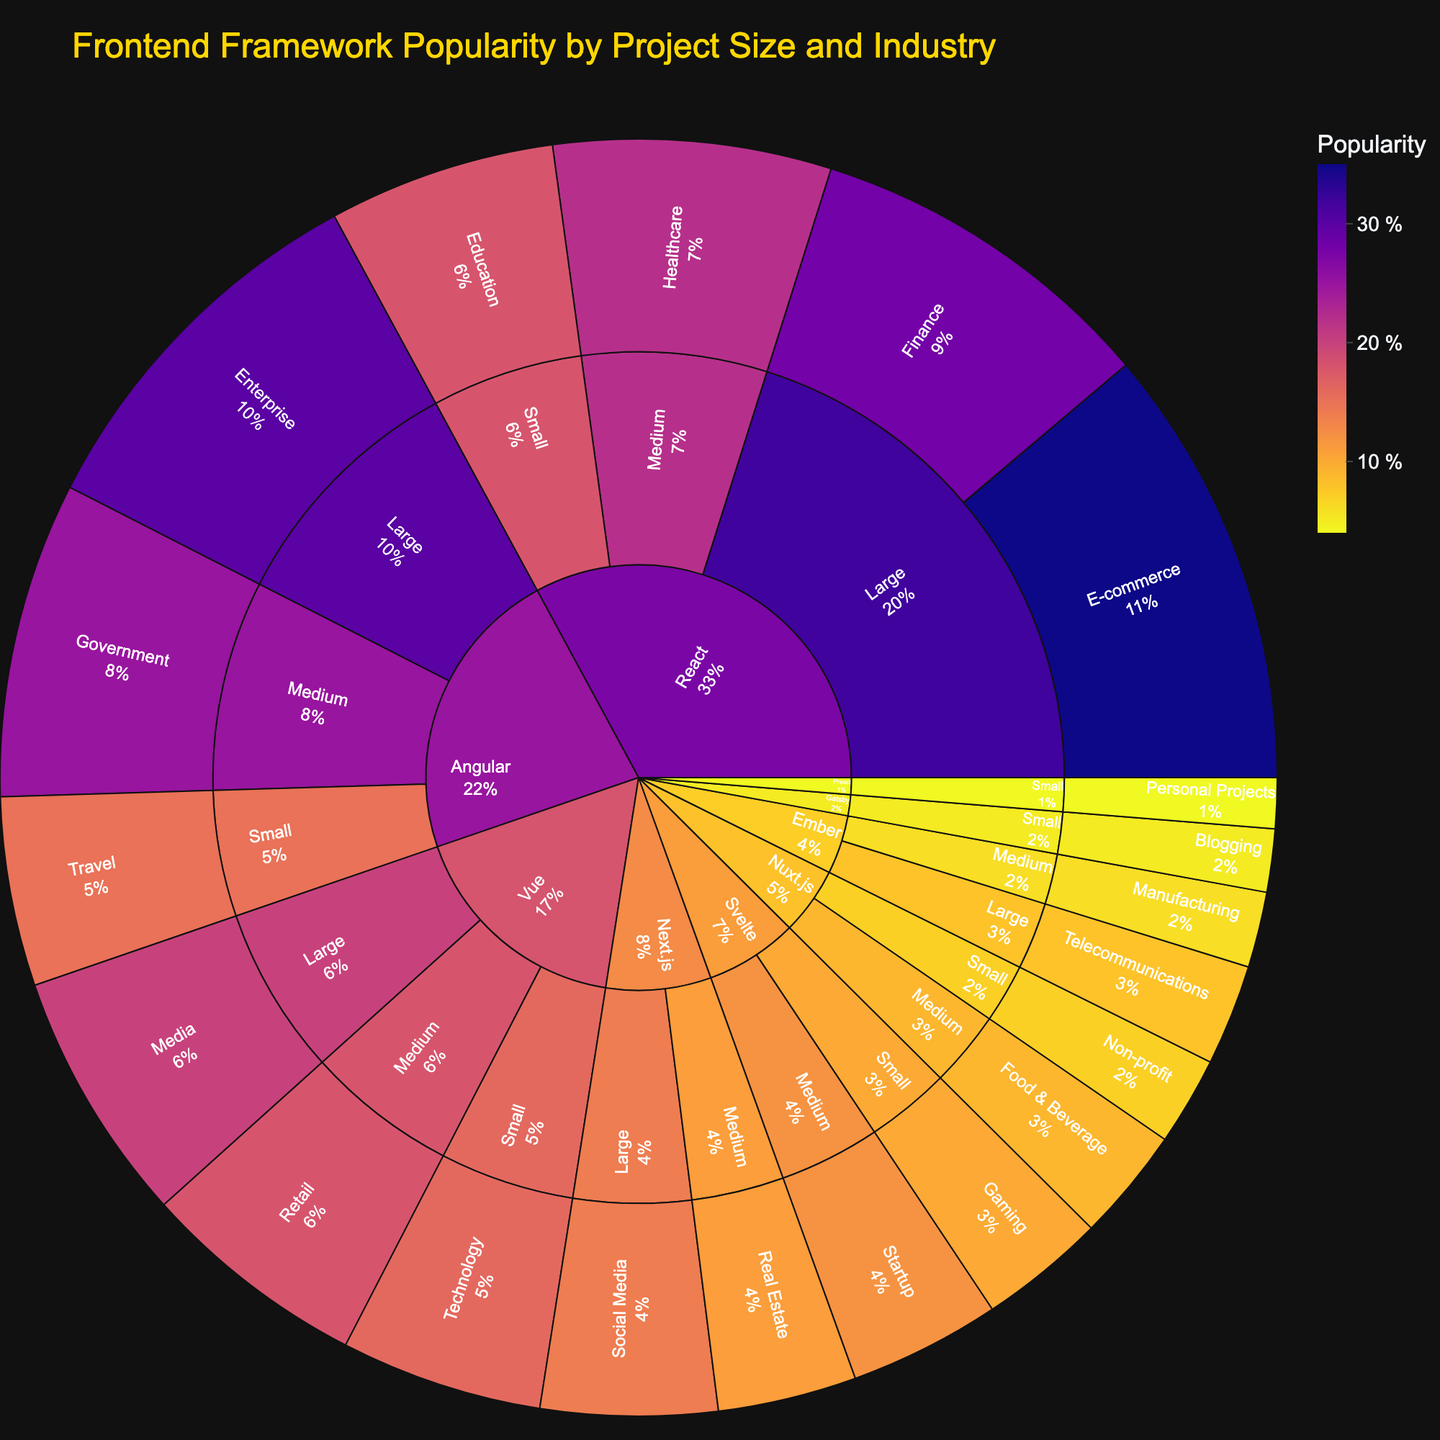Which framework is the most popular within the E-commerce industry? In the sunburst plot, you can trace the path from the "E-commerce" industry upward to see which framework it belongs to. The "React" framework is connected to the "E-commerce" industry, indicated by the highest popularity value of 35.
Answer: React What is the combined popularity of React in small and medium-sized projects? First, identify the popularity values for React in small and medium project sizes. According to the plot, React has a popularity of 18 in small projects and 22 in medium projects. Summing these values gives 18 + 22.
Answer: 40 Which industry has the least popular framework, and what is its popularity value? By analyzing the sunburst plot, locate the smallest segment within each industry's branching. The "Personal Projects" industry linked to "Preact" has the smallest value, which is 4.
Answer: Personal Projects, 4 Is Angular more popular than Vue in large-sized projects? To find this comparison, trace the segments for both Angular and Vue in the large-sized projects. Angular has 30 popularity in large projects, while Vue has 20. Hence, Angular's popularity exceeds Vue's in this category.
Answer: Yes How many frameworks are used in the "Small" project size? Observe the number of segments branching from the "Small" project size in the sunburst plot. The small project size shows segments for four frameworks: React, Angular, Vue, Svelte, Nuxt.js, Gatsby, and Preact.
Answer: 6 What is the average popularity for all industries in medium-sized projects where the framework is Vue? The sunburst plot shows Vue in the "Retail" industry with a popularity of 18 in medium-sized projects. Since "Retail" is the only industry for Vue in this size category, the average value is just the single value of 18.
Answer: 18 Compare and identify which framework has a higher total popularity across all industries – Svelte or Ember? In the plot, sum up the popularity values for all industries under both frameworks. For Svelte: 12 (Startup) + 10 (Gaming) = 22. For Ember: 8 (Telecommunications) + 6 (Manufacturing) = 14. Svelte has a higher total popularity.
Answer: Svelte Which framework is most popular in the Enterprise industry, and what is the popularity value? Navigate to the Enterprise industry segment in the plot and observe the connected framework segment. The framework associated with Enterprise is Angular with a popularity value of 30.
Answer: Angular, 30 What is the total popularity of frameworks in medium-sized projects for the industries "Government" and "Real Estate"? Identify the popularity for "Government" under Angular (25) and for "Real Estate" under Next.js (11). Adding these values, 25 + 11.
Answer: 36 